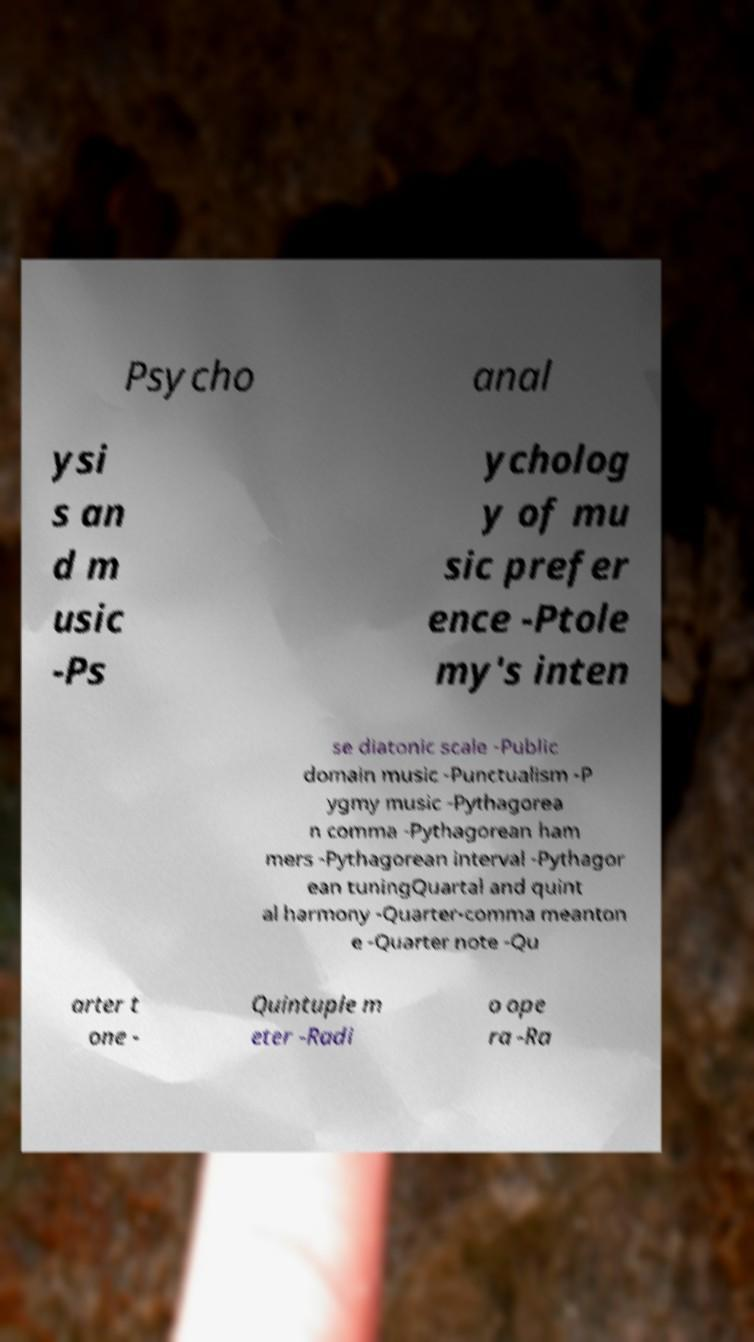There's text embedded in this image that I need extracted. Can you transcribe it verbatim? Psycho anal ysi s an d m usic -Ps ycholog y of mu sic prefer ence -Ptole my's inten se diatonic scale -Public domain music -Punctualism -P ygmy music -Pythagorea n comma -Pythagorean ham mers -Pythagorean interval -Pythagor ean tuningQuartal and quint al harmony -Quarter-comma meanton e -Quarter note -Qu arter t one - Quintuple m eter -Radi o ope ra -Ra 